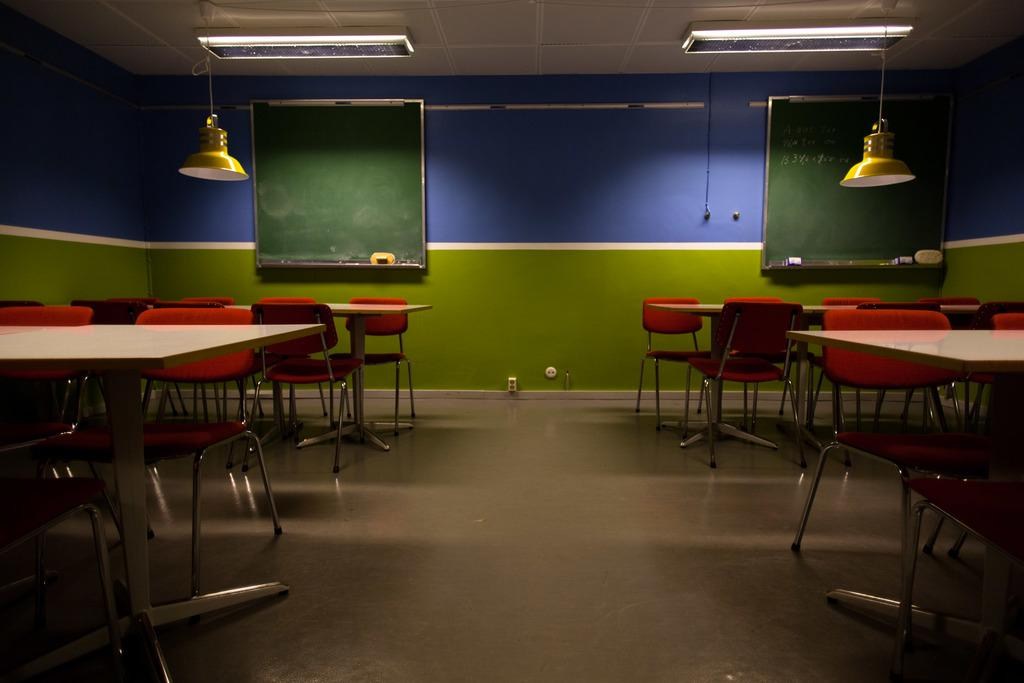What type of furniture is present in the image? There are chairs and tables in the image. What can be seen on the ceiling in the image? There are lights on the ceiling in the image. What type of surface is present for writing or displaying information? There are green boards in the image. How much profit can be made from the chairs in the image? There is no information about profit in the image, as it only shows chairs, tables, lights, and green boards. 